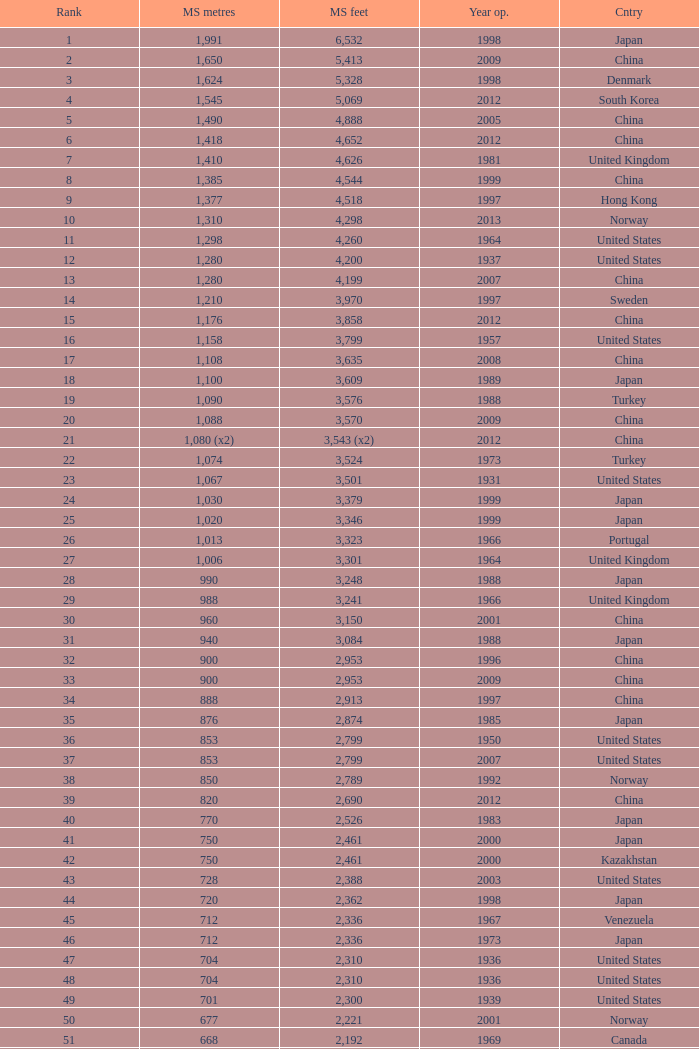What is the maximum rank achieved for a 430-meter main span in years later than 2010? 94.0. 